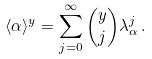<formula> <loc_0><loc_0><loc_500><loc_500>\langle \alpha \rangle ^ { y } = \sum _ { j = 0 } ^ { \infty } \binom { y } { j } \lambda _ { \alpha } ^ { j } \, .</formula> 